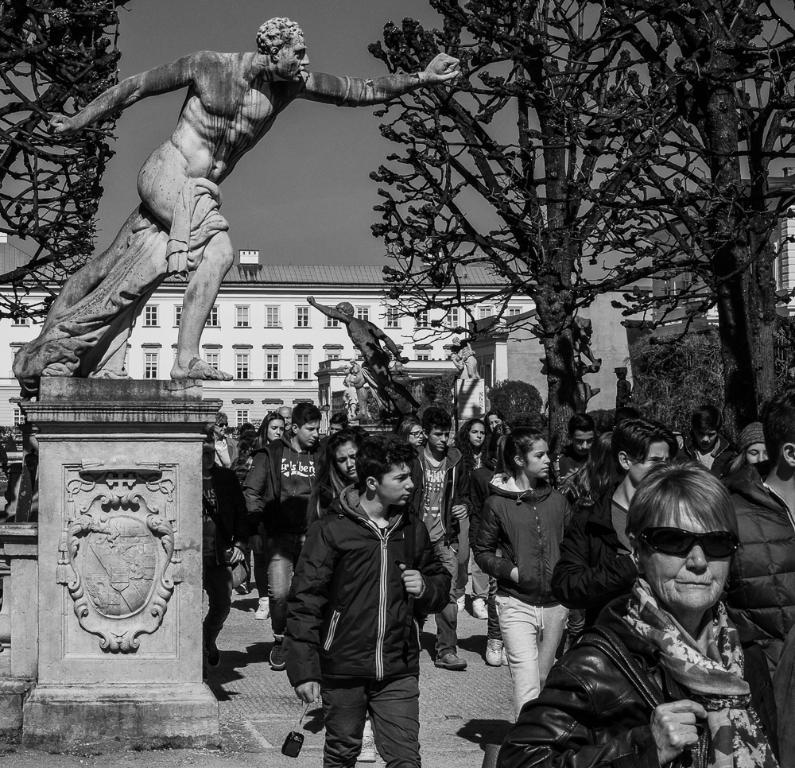What is the main subject in the foreground of the image? There is a crowd in the foreground of the image. Where is the crowd located? The crowd is on the road. What other notable feature is present in the foreground of the image? There is a person's statue in the foreground of the image. What can be seen in the background of the image? There are trees, buildings, and the sky visible in the background of the image. What type of bean is being sold by the newsstand in the image? There is no newsstand or bean present in the image. What level of the building is the crowd standing on in the image? The image does not provide information about the level of the building the crowd is standing on. 